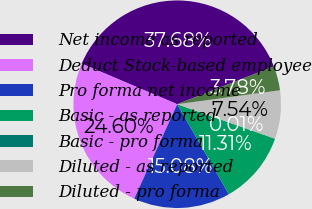Convert chart to OTSL. <chart><loc_0><loc_0><loc_500><loc_500><pie_chart><fcel>Net income as reported<fcel>Deduct Stock-based employee<fcel>Pro forma net income<fcel>Basic - as reported<fcel>Basic - pro forma<fcel>Diluted - as reported<fcel>Diluted - pro forma<nl><fcel>37.68%<fcel>24.6%<fcel>15.08%<fcel>11.31%<fcel>0.01%<fcel>7.54%<fcel>3.78%<nl></chart> 